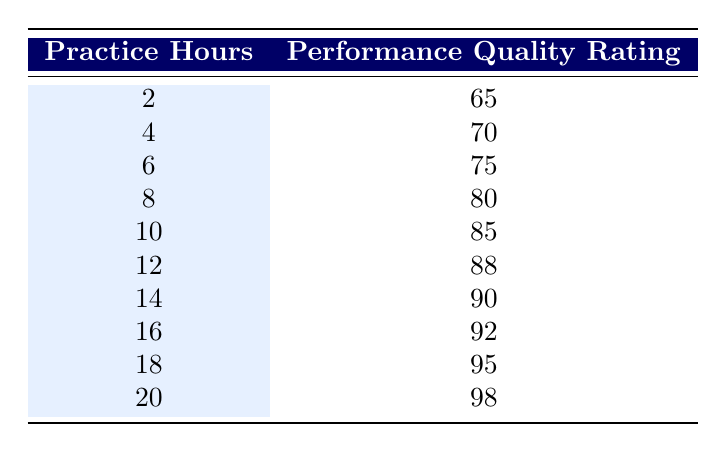What is the performance quality rating for 10 practice hours? The table shows that for 10 practice hours, the corresponding performance quality rating is listed directly next to that value. Therefore, the rating is 85.
Answer: 85 What are the performance quality ratings for 12 and 14 practice hours? By looking at the table, the performance quality rating for 12 practice hours is 88, and for 14 practice hours, it is 90.
Answer: 88 and 90 What is the total performance quality rating for all practice hours combined? To find the total, sum all the performance quality ratings: 65 + 70 + 75 + 80 + 85 + 88 + 90 + 92 + 95 + 98 =  918.
Answer: 918 Is the performance quality rating higher for 18 practice hours than for 14 practice hours? The table indicates that the performance quality rating for 18 hours is 95, while for 14 hours it is 90. Since 95 is greater than 90, the answer is yes.
Answer: Yes What is the difference in performance quality ratings between 2 and 20 practice hours? The performance rating for 2 practice hours is 65, and for 20 practice hours, it is 98. The difference is calculated by subtracting: 98 - 65 = 33.
Answer: 33 What is the average performance quality rating from the table? First, sum all the performance ratings, which is 918 (calculated earlier), and then divide by the number of data points, which is 10. Therefore, 918 / 10 = 91.8.
Answer: 91.8 How many practice hours correspond to a performance quality rating of 80 or higher? Referring to the table, we identify the ratings of 80, 85, 88, 90, 92, 95, and 98. The corresponding practice hours for these ratings are 8, 10, 12, 14, 16, 18, and 20. This results in 7 instances.
Answer: 7 Are any of the performance quality ratings below 70? The table lists the ratings starting from 65 at 2 practice hours, which is below 70. Therefore, there is at least one rating below 70.
Answer: Yes What percentage of the highest performance quality rating (98) is the rating for 16 practice hours (92)? The percentage is calculated by dividing the 92 by 98 and multiplying by 100: (92 / 98) * 100 = 93.88%.
Answer: 93.88% 